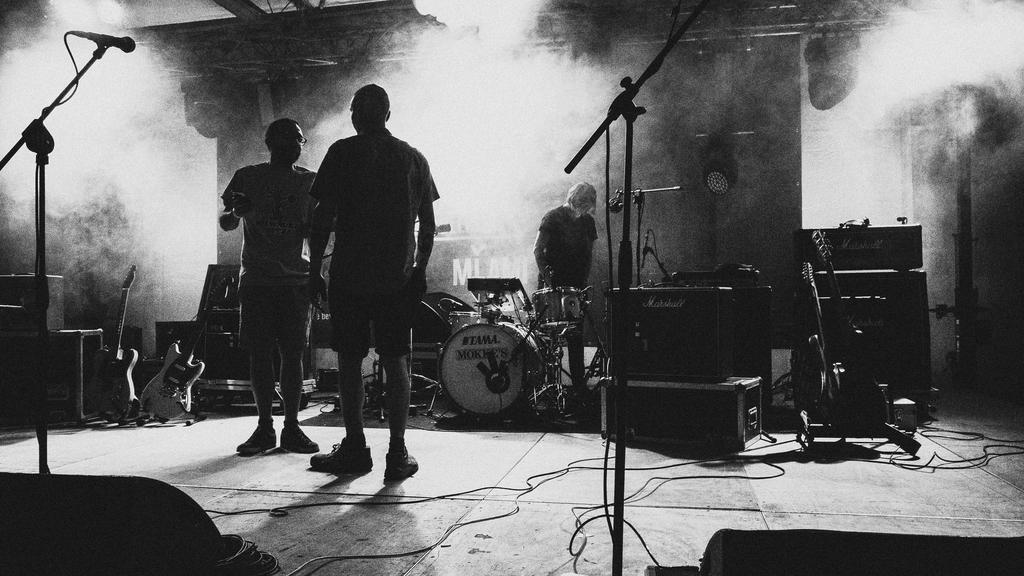How many people are in the image? There are three men in the image. Where are the men located in the image? The men are standing on a dais. What objects are present on the dais with the men? There are musical instruments, drums, and microphones present on the dais. What type of behavior is displayed by the men's brothers in the image? There is no mention of the men's brothers in the image, and their behavior cannot be determined from the provided facts. 